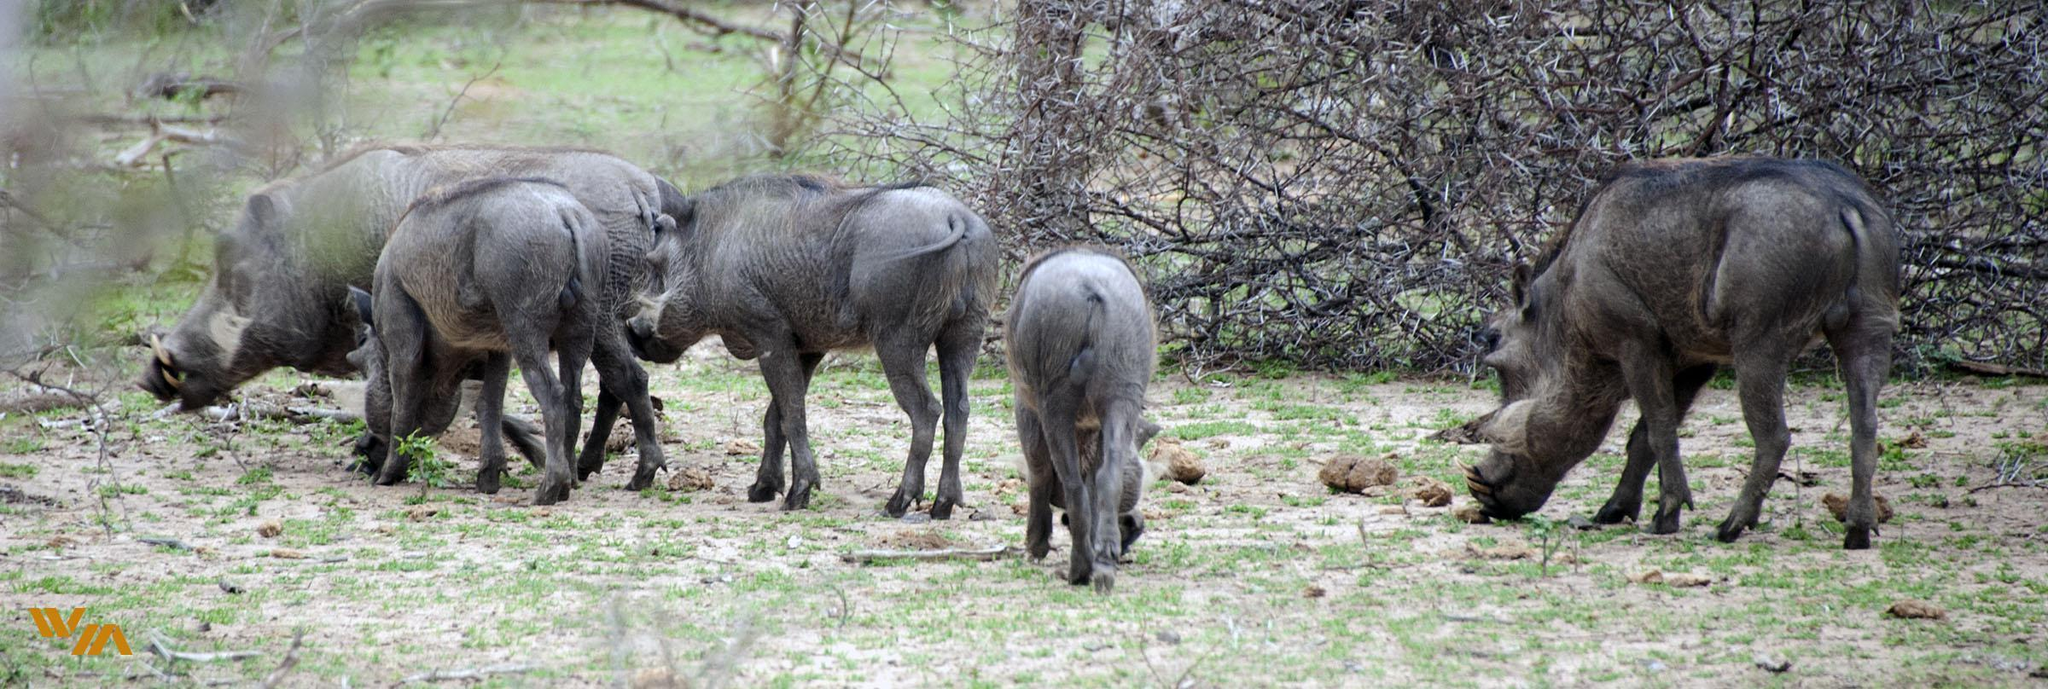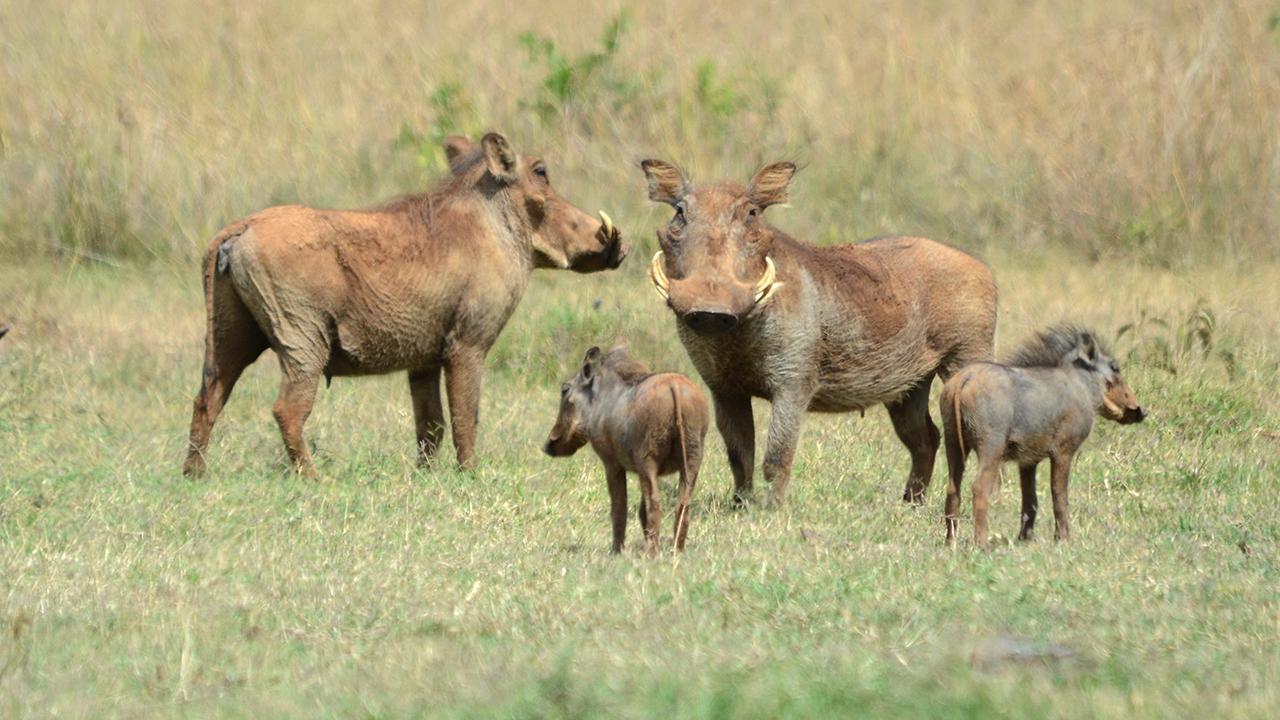The first image is the image on the left, the second image is the image on the right. Considering the images on both sides, is "There are 9 or more warthogs, and there are only brown ones in one of the pictures, and only black ones in the other picture." valid? Answer yes or no. Yes. The first image is the image on the left, the second image is the image on the right. Assess this claim about the two images: "There is only one wart hog in the image on the left.". Correct or not? Answer yes or no. No. 